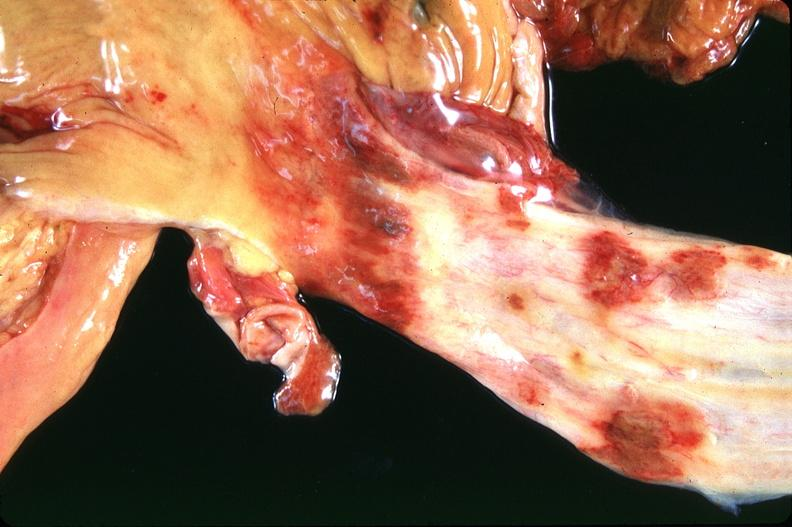s gastrointestinal present?
Answer the question using a single word or phrase. Yes 